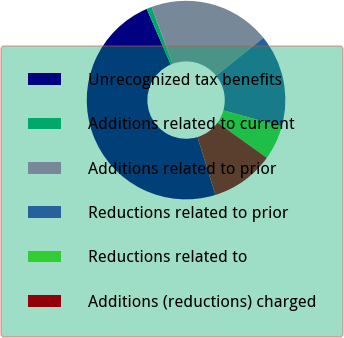Convert chart. <chart><loc_0><loc_0><loc_500><loc_500><pie_chart><fcel>Unrecognized tax benefits<fcel>Additions related to current<fcel>Additions related to prior<fcel>Reductions related to prior<fcel>Reductions related to<fcel>Additions (reductions) charged<nl><fcel>48.3%<fcel>0.85%<fcel>19.83%<fcel>15.09%<fcel>5.6%<fcel>10.34%<nl></chart> 